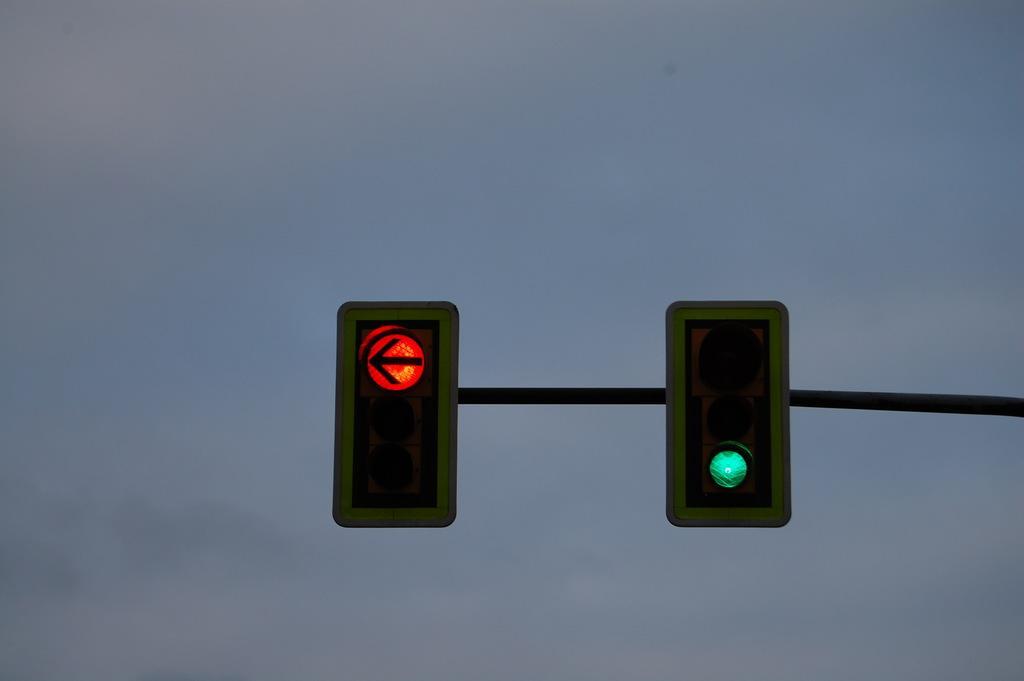In one or two sentences, can you explain what this image depicts? In the image there is a pole with traffic signals. Behind the pole there is sky. 